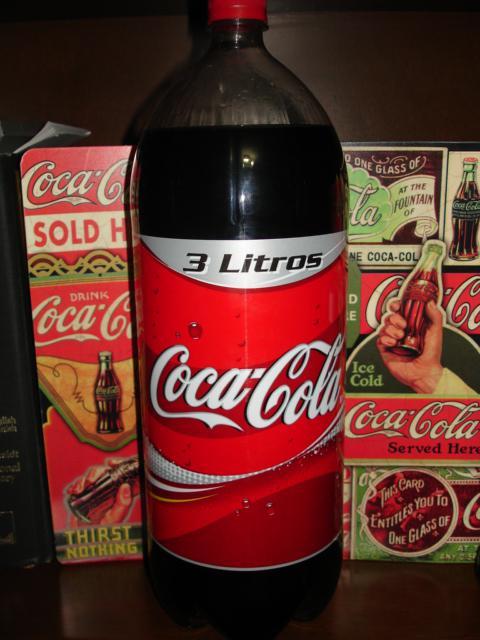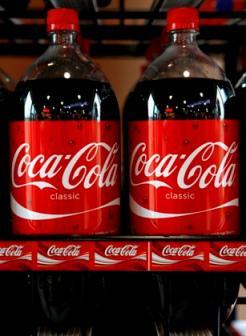The first image is the image on the left, the second image is the image on the right. Given the left and right images, does the statement "There are exactly three bottles of soda." hold true? Answer yes or no. Yes. The first image is the image on the left, the second image is the image on the right. Considering the images on both sides, is "The left image features one full bottle of cola with a red wrapper standing upright, and the right image contains two full bottles of cola with red wrappers positioned side-by-side." valid? Answer yes or no. Yes. 